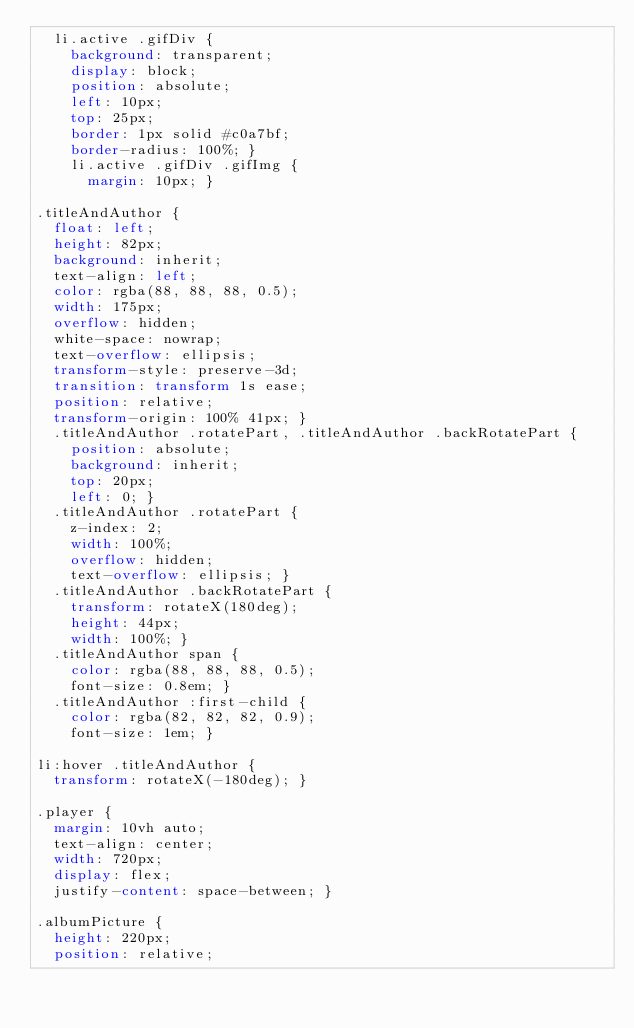<code> <loc_0><loc_0><loc_500><loc_500><_CSS_>  li.active .gifDiv {
    background: transparent;
    display: block;
    position: absolute;
    left: 10px;
    top: 25px;
    border: 1px solid #c0a7bf;
    border-radius: 100%; }
    li.active .gifDiv .gifImg {
      margin: 10px; }

.titleAndAuthor {
  float: left;
  height: 82px;
  background: inherit;
  text-align: left;
  color: rgba(88, 88, 88, 0.5);
  width: 175px;
  overflow: hidden;
  white-space: nowrap;
  text-overflow: ellipsis;
  transform-style: preserve-3d;
  transition: transform 1s ease;
  position: relative;
  transform-origin: 100% 41px; }
  .titleAndAuthor .rotatePart, .titleAndAuthor .backRotatePart {
    position: absolute;
    background: inherit;
    top: 20px;
    left: 0; }
  .titleAndAuthor .rotatePart {
    z-index: 2;
    width: 100%;
    overflow: hidden;
    text-overflow: ellipsis; }
  .titleAndAuthor .backRotatePart {
    transform: rotateX(180deg);
    height: 44px;
    width: 100%; }
  .titleAndAuthor span {
    color: rgba(88, 88, 88, 0.5);
    font-size: 0.8em; }
  .titleAndAuthor :first-child {
    color: rgba(82, 82, 82, 0.9);
    font-size: 1em; }

li:hover .titleAndAuthor {
  transform: rotateX(-180deg); }

.player {
  margin: 10vh auto;
  text-align: center;
  width: 720px;
  display: flex;
  justify-content: space-between; }

.albumPicture {
  height: 220px;
  position: relative;</code> 